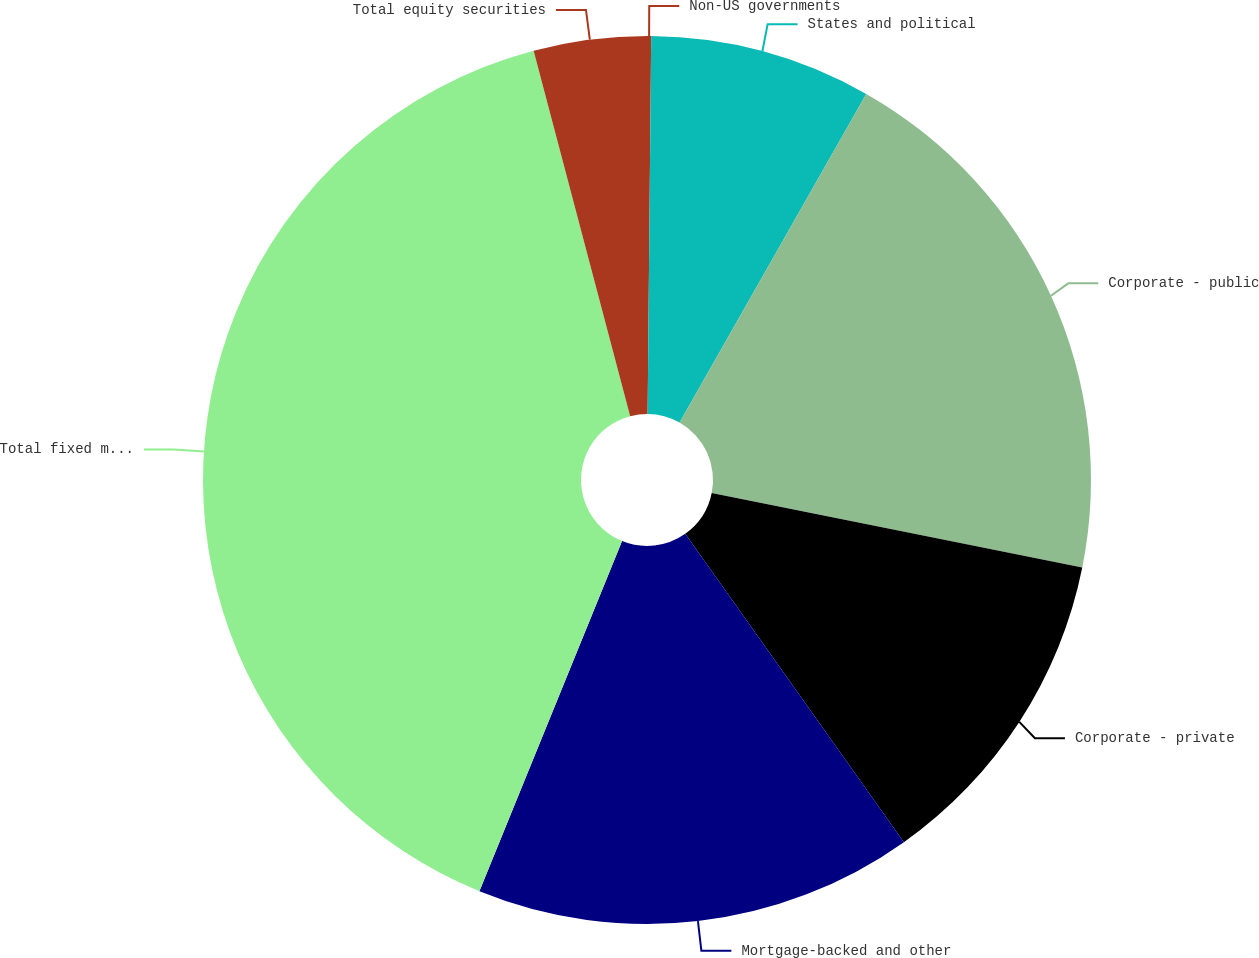Convert chart. <chart><loc_0><loc_0><loc_500><loc_500><pie_chart><fcel>Non-US governments<fcel>States and political<fcel>Corporate - public<fcel>Corporate - private<fcel>Mortgage-backed and other<fcel>Total fixed maturities<fcel>Total equity securities<nl><fcel>0.15%<fcel>8.07%<fcel>19.94%<fcel>12.02%<fcel>15.98%<fcel>39.73%<fcel>4.11%<nl></chart> 